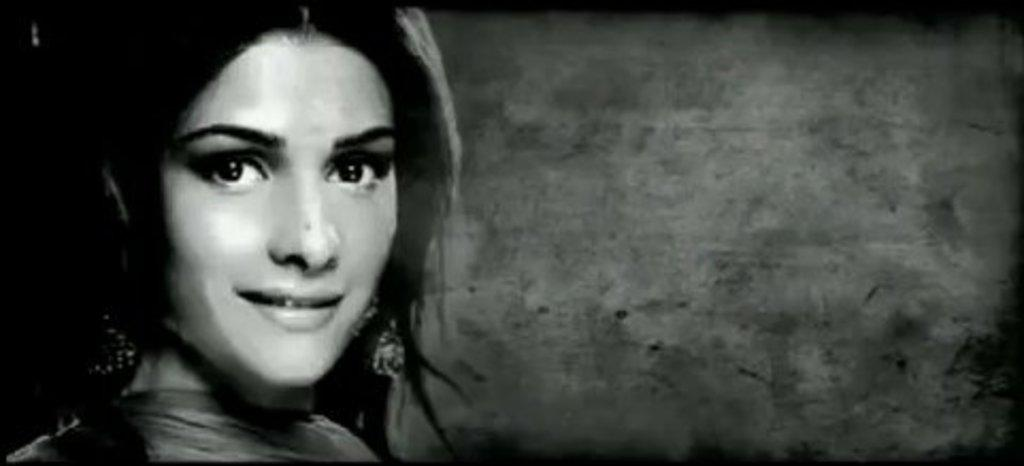What is present on the left side of the image? There is a woman in the image. Can you describe the woman's expression in the image? The woman is smiling. What type of toys can be seen in the image? There are no toys present in the image. What scene is depicted in the image? The image only shows a woman on the left side of the image, and no specific scene is depicted. 